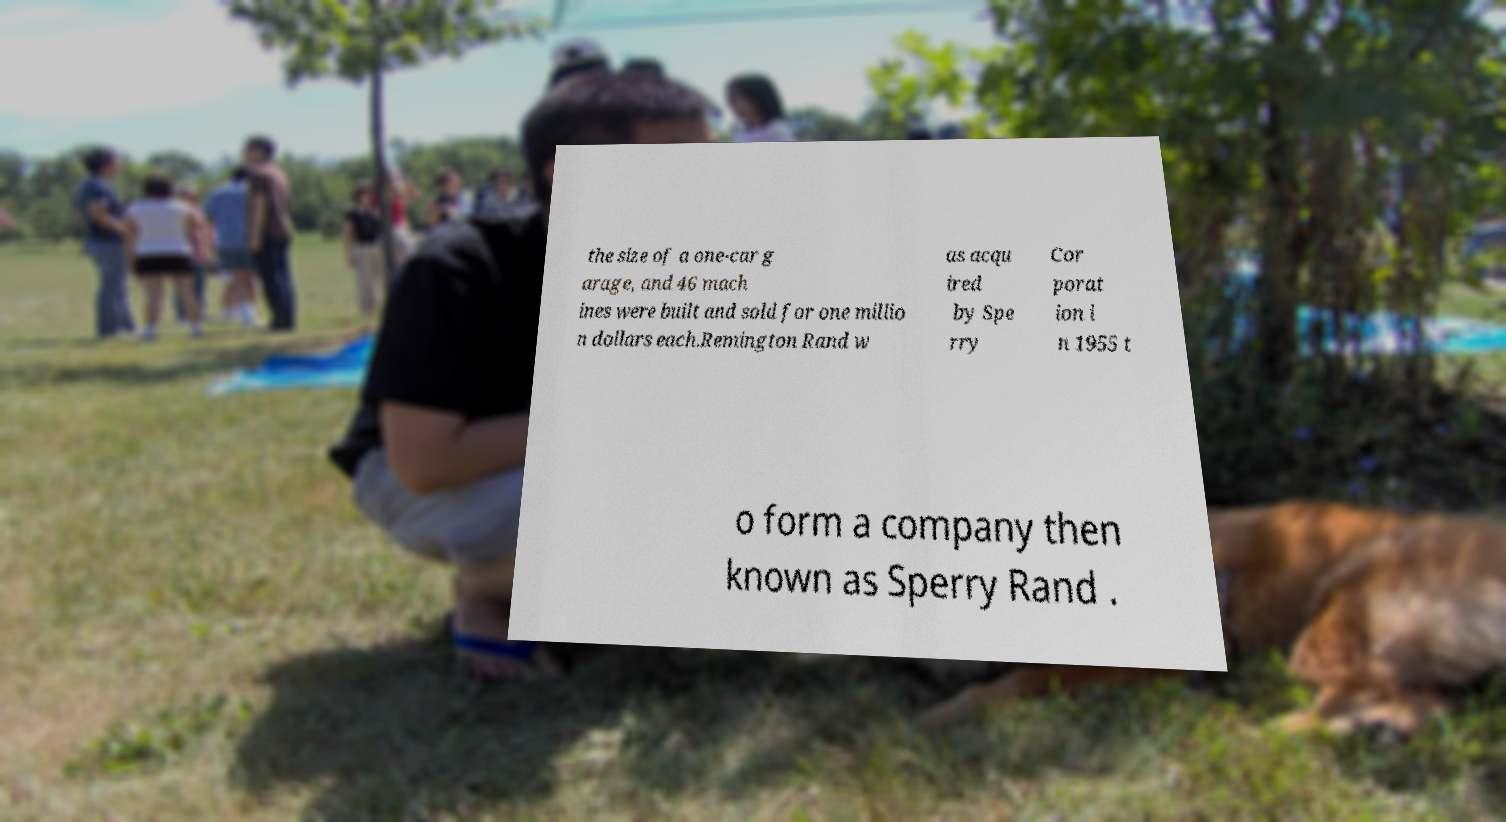Can you accurately transcribe the text from the provided image for me? the size of a one-car g arage, and 46 mach ines were built and sold for one millio n dollars each.Remington Rand w as acqu ired by Spe rry Cor porat ion i n 1955 t o form a company then known as Sperry Rand . 